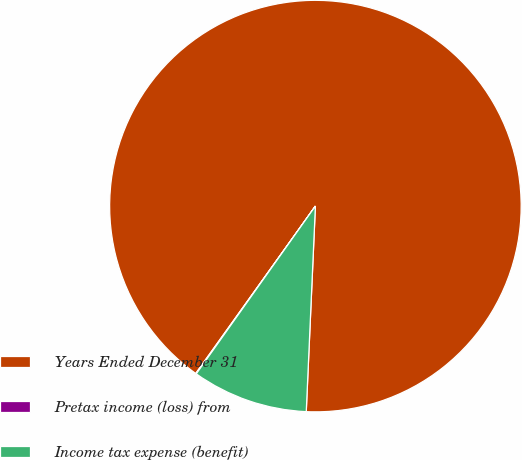Convert chart. <chart><loc_0><loc_0><loc_500><loc_500><pie_chart><fcel>Years Ended December 31<fcel>Pretax income (loss) from<fcel>Income tax expense (benefit)<nl><fcel>90.83%<fcel>0.05%<fcel>9.12%<nl></chart> 